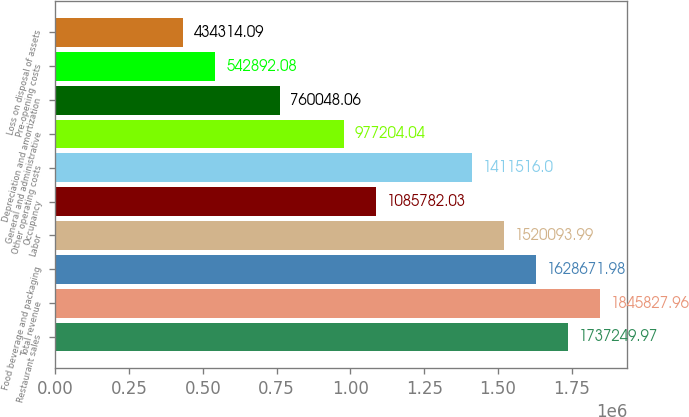Convert chart to OTSL. <chart><loc_0><loc_0><loc_500><loc_500><bar_chart><fcel>Restaurant sales<fcel>Total revenue<fcel>Food beverage and packaging<fcel>Labor<fcel>Occupancy<fcel>Other operating costs<fcel>General and administrative<fcel>Depreciation and amortization<fcel>Pre-opening costs<fcel>Loss on disposal of assets<nl><fcel>1.73725e+06<fcel>1.84583e+06<fcel>1.62867e+06<fcel>1.52009e+06<fcel>1.08578e+06<fcel>1.41152e+06<fcel>977204<fcel>760048<fcel>542892<fcel>434314<nl></chart> 